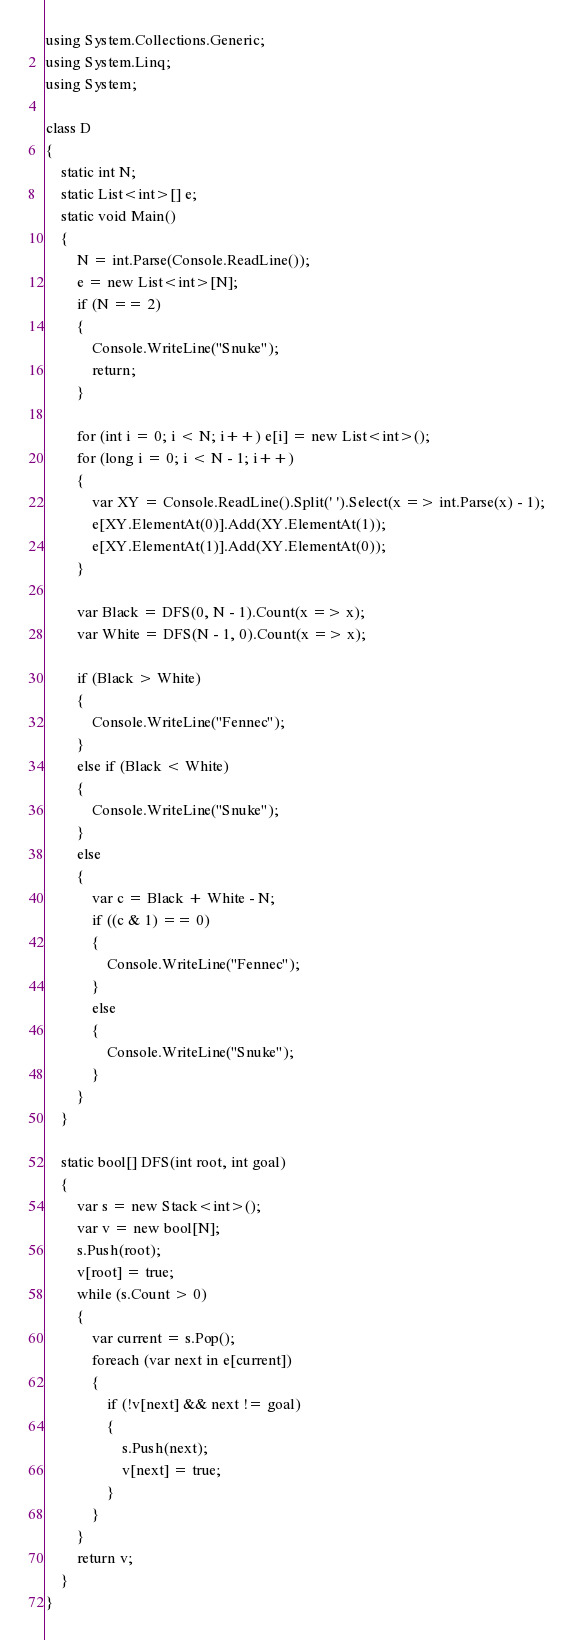Convert code to text. <code><loc_0><loc_0><loc_500><loc_500><_C#_>using System.Collections.Generic;
using System.Linq;
using System;

class D
{
    static int N;
    static List<int>[] e;
    static void Main()
    {
        N = int.Parse(Console.ReadLine());
        e = new List<int>[N];
        if (N == 2)
        {
            Console.WriteLine("Snuke");
            return;
        }

        for (int i = 0; i < N; i++) e[i] = new List<int>();
        for (long i = 0; i < N - 1; i++)
        {
            var XY = Console.ReadLine().Split(' ').Select(x => int.Parse(x) - 1);
            e[XY.ElementAt(0)].Add(XY.ElementAt(1));
            e[XY.ElementAt(1)].Add(XY.ElementAt(0));
        }

        var Black = DFS(0, N - 1).Count(x => x);
        var White = DFS(N - 1, 0).Count(x => x);
        
        if (Black > White)
        {
            Console.WriteLine("Fennec");
        }
        else if (Black < White)
        {
            Console.WriteLine("Snuke");
        }
        else
        {
            var c = Black + White - N;
            if ((c & 1) == 0)
            {
                Console.WriteLine("Fennec");
            }
            else
            {
                Console.WriteLine("Snuke");
            }
        }
    }

    static bool[] DFS(int root, int goal)
    {
        var s = new Stack<int>();
        var v = new bool[N];
        s.Push(root);
        v[root] = true;
        while (s.Count > 0)
        {
            var current = s.Pop();
            foreach (var next in e[current])
            {
                if (!v[next] && next != goal)
                {
                    s.Push(next);
                    v[next] = true;
                }
            }
        }
        return v;
    }
}
</code> 